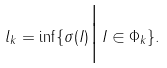<formula> <loc_0><loc_0><loc_500><loc_500>l _ { k } = \inf \{ \sigma ( I ) \Big { | } \, I \in \Phi _ { k } \} .</formula> 